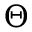Convert formula to latex. <formula><loc_0><loc_0><loc_500><loc_500>\Theta</formula> 